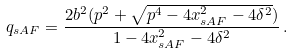<formula> <loc_0><loc_0><loc_500><loc_500>q _ { s A F } = \frac { 2 b ^ { 2 } ( p ^ { 2 } + \sqrt { p ^ { 4 } - 4 x _ { s A F } ^ { 2 } - 4 \delta ^ { 2 } } ) } { 1 - 4 x _ { s A F } ^ { 2 } - 4 \delta ^ { 2 } } \, . \\</formula> 